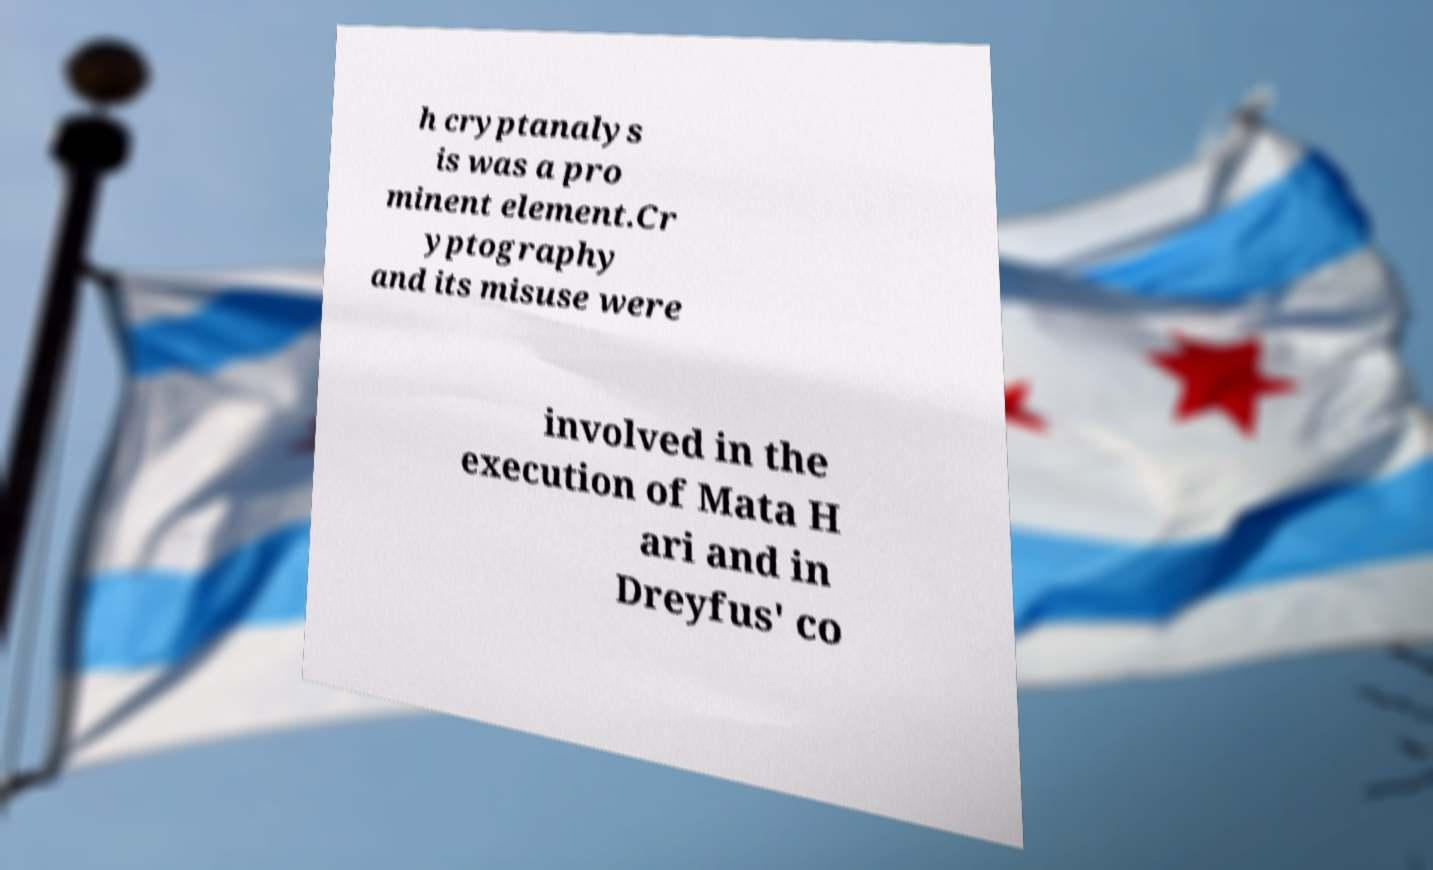Could you assist in decoding the text presented in this image and type it out clearly? h cryptanalys is was a pro minent element.Cr yptography and its misuse were involved in the execution of Mata H ari and in Dreyfus' co 